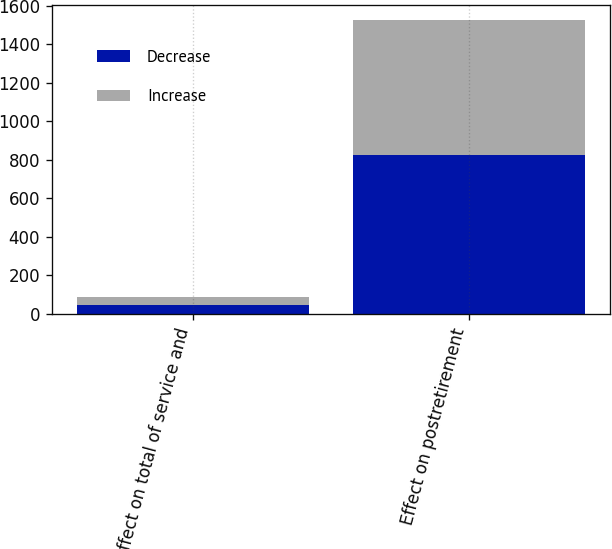Convert chart. <chart><loc_0><loc_0><loc_500><loc_500><stacked_bar_chart><ecel><fcel>Effect on total of service and<fcel>Effect on postretirement<nl><fcel>Decrease<fcel>46<fcel>827<nl><fcel>Increase<fcel>40<fcel>700<nl></chart> 